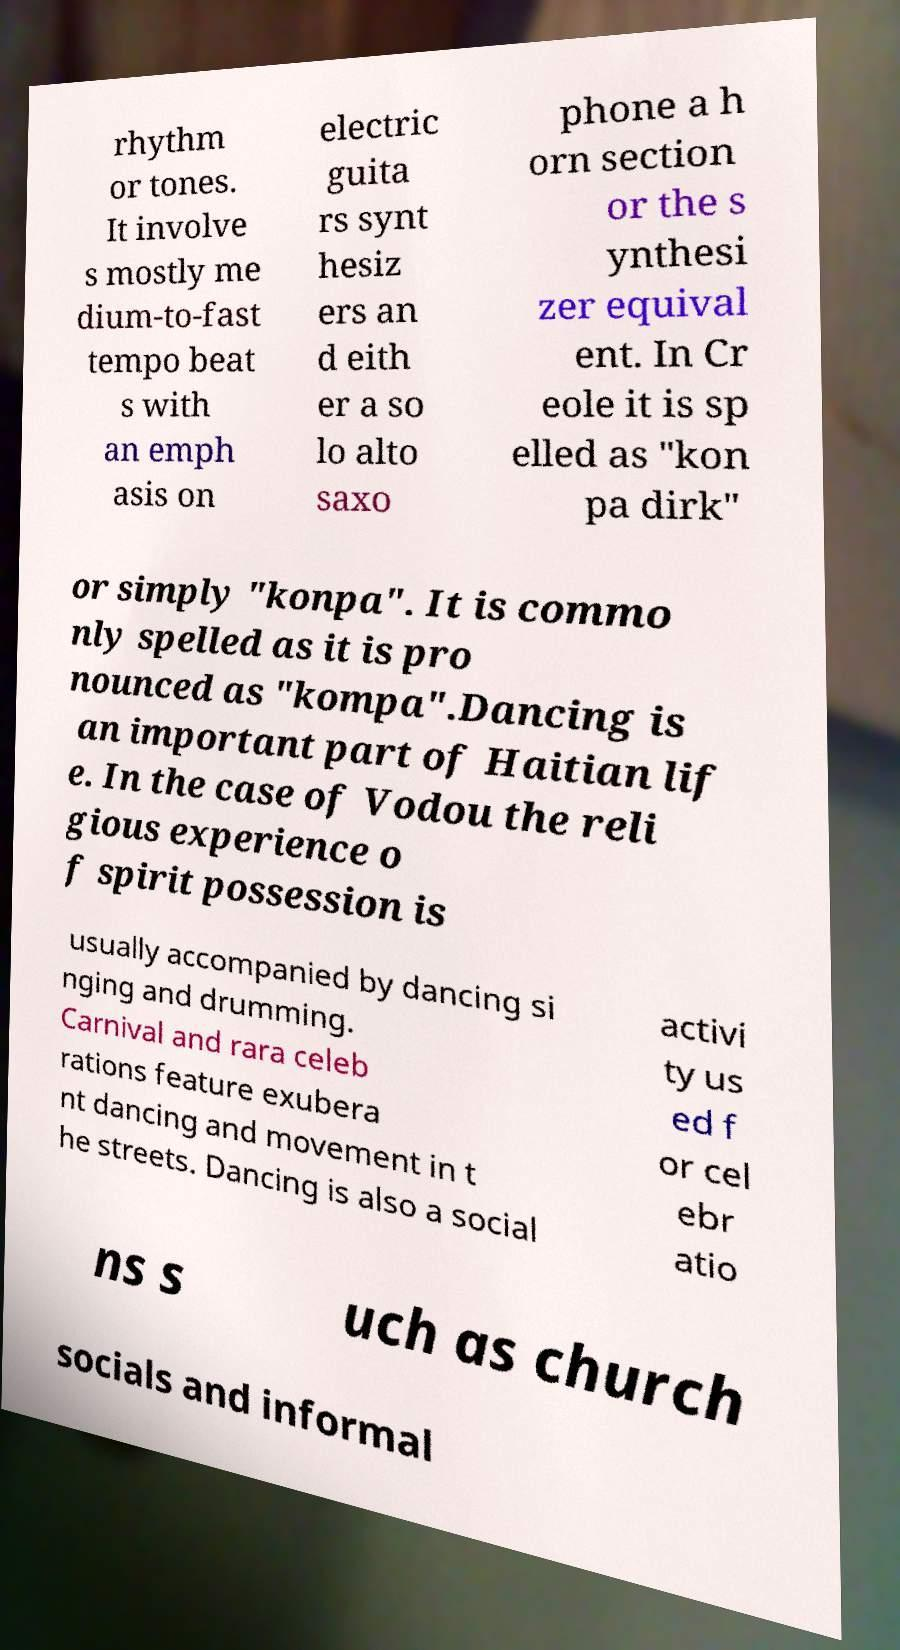Please read and relay the text visible in this image. What does it say? rhythm or tones. It involve s mostly me dium-to-fast tempo beat s with an emph asis on electric guita rs synt hesiz ers an d eith er a so lo alto saxo phone a h orn section or the s ynthesi zer equival ent. In Cr eole it is sp elled as "kon pa dirk" or simply "konpa". It is commo nly spelled as it is pro nounced as "kompa".Dancing is an important part of Haitian lif e. In the case of Vodou the reli gious experience o f spirit possession is usually accompanied by dancing si nging and drumming. Carnival and rara celeb rations feature exubera nt dancing and movement in t he streets. Dancing is also a social activi ty us ed f or cel ebr atio ns s uch as church socials and informal 